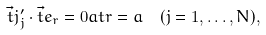Convert formula to latex. <formula><loc_0><loc_0><loc_500><loc_500>\vec { t } { j } _ { j } ^ { \prime } \cdot \vec { t } { e } _ { r } = 0 a t r = a \ \ ( j = 1 , \dots , N ) ,</formula> 